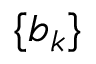Convert formula to latex. <formula><loc_0><loc_0><loc_500><loc_500>\{ b _ { k } \}</formula> 